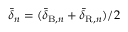<formula> <loc_0><loc_0><loc_500><loc_500>\bar { \delta } _ { n } = ( \bar { \delta } _ { B , n } + \bar { \delta } _ { R , n } ) / 2</formula> 